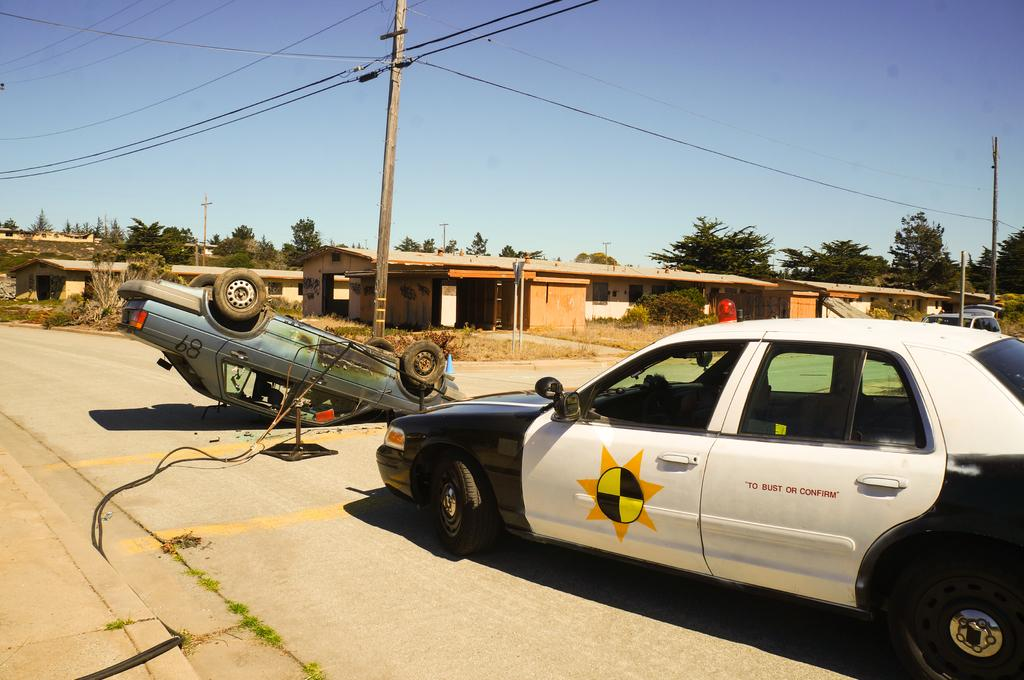<image>
Summarize the visual content of the image. A white and black car has the following on the back door, "To bust or Confirm." 